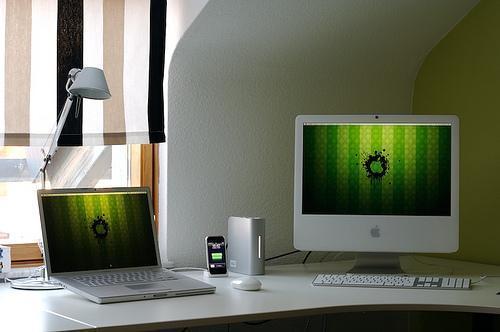How many computers are there?
Give a very brief answer. 2. How many mouses do you see?
Give a very brief answer. 1. How many laptops can you see?
Give a very brief answer. 1. How many wine bottles can be seen?
Give a very brief answer. 0. 